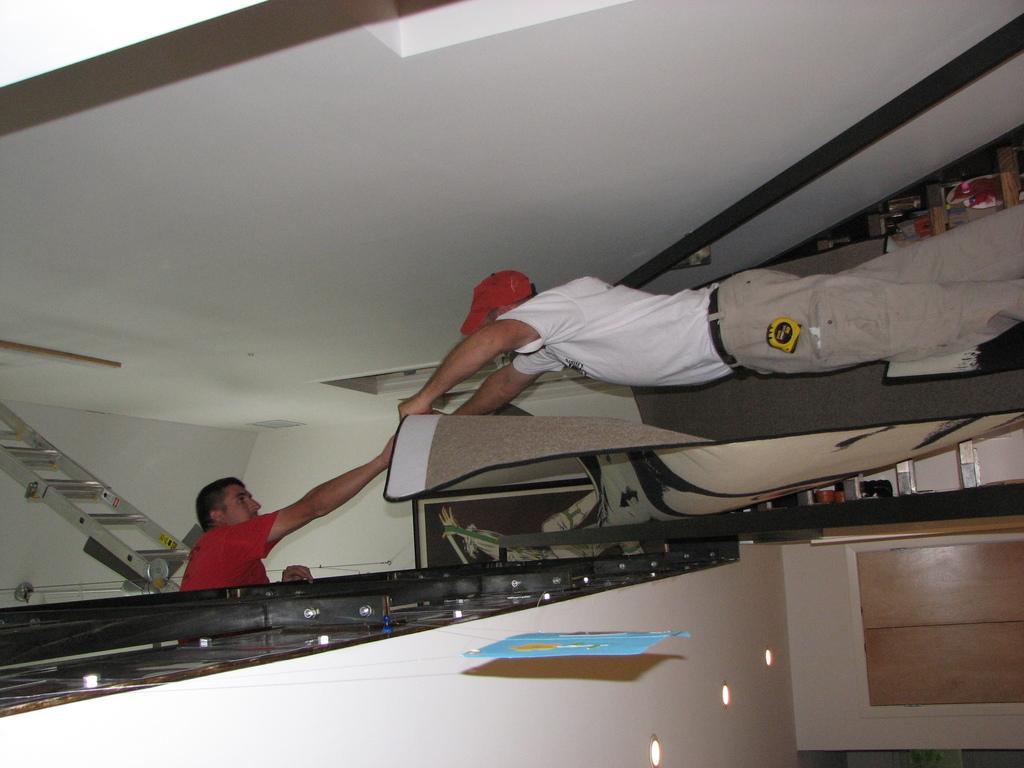Please provide a concise description of this image. In this picture we can see two people, ladder, kite, roof, walls, lights and some objects. 